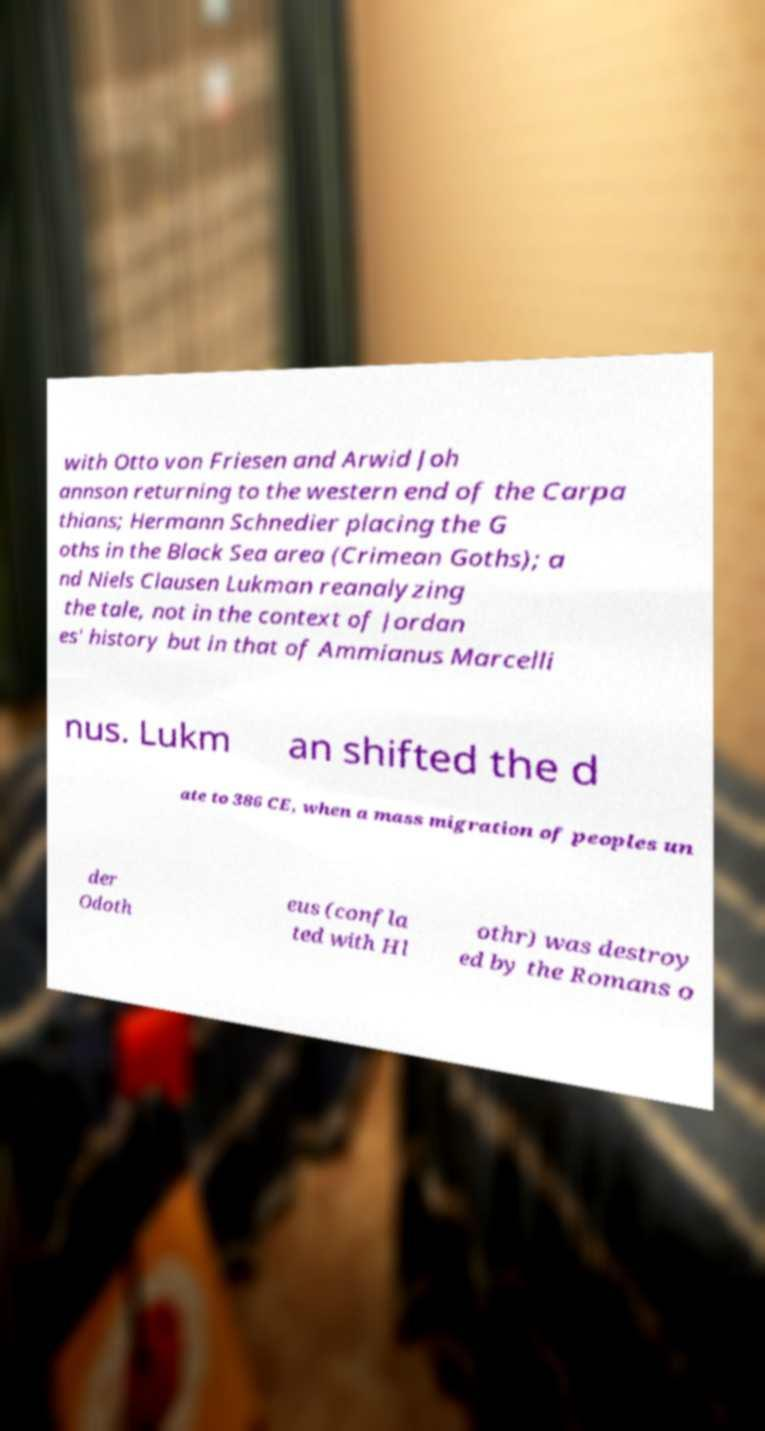Please read and relay the text visible in this image. What does it say? with Otto von Friesen and Arwid Joh annson returning to the western end of the Carpa thians; Hermann Schnedier placing the G oths in the Black Sea area (Crimean Goths); a nd Niels Clausen Lukman reanalyzing the tale, not in the context of Jordan es' history but in that of Ammianus Marcelli nus. Lukm an shifted the d ate to 386 CE, when a mass migration of peoples un der Odoth eus (confla ted with Hl othr) was destroy ed by the Romans o 